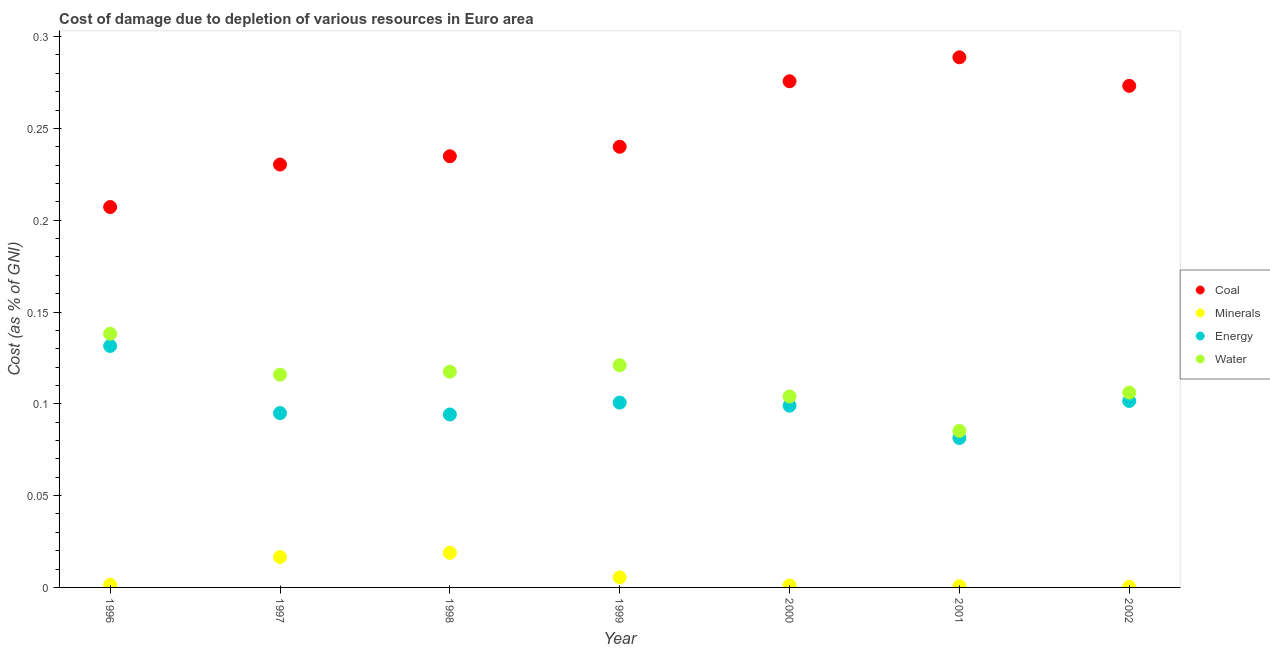How many different coloured dotlines are there?
Provide a short and direct response. 4. Is the number of dotlines equal to the number of legend labels?
Your answer should be compact. Yes. What is the cost of damage due to depletion of water in 1997?
Give a very brief answer. 0.12. Across all years, what is the maximum cost of damage due to depletion of water?
Provide a short and direct response. 0.14. Across all years, what is the minimum cost of damage due to depletion of coal?
Your answer should be very brief. 0.21. In which year was the cost of damage due to depletion of energy maximum?
Give a very brief answer. 1996. What is the total cost of damage due to depletion of coal in the graph?
Give a very brief answer. 1.75. What is the difference between the cost of damage due to depletion of water in 2000 and that in 2002?
Your answer should be very brief. -0. What is the difference between the cost of damage due to depletion of coal in 2001 and the cost of damage due to depletion of minerals in 2000?
Your response must be concise. 0.29. What is the average cost of damage due to depletion of coal per year?
Your answer should be compact. 0.25. In the year 2001, what is the difference between the cost of damage due to depletion of energy and cost of damage due to depletion of coal?
Ensure brevity in your answer.  -0.21. In how many years, is the cost of damage due to depletion of coal greater than 0.2 %?
Your answer should be very brief. 7. What is the ratio of the cost of damage due to depletion of water in 1998 to that in 1999?
Provide a succinct answer. 0.97. Is the cost of damage due to depletion of coal in 1997 less than that in 2002?
Ensure brevity in your answer.  Yes. Is the difference between the cost of damage due to depletion of water in 2001 and 2002 greater than the difference between the cost of damage due to depletion of minerals in 2001 and 2002?
Offer a terse response. No. What is the difference between the highest and the second highest cost of damage due to depletion of water?
Keep it short and to the point. 0.02. What is the difference between the highest and the lowest cost of damage due to depletion of minerals?
Your answer should be very brief. 0.02. Is the sum of the cost of damage due to depletion of minerals in 1997 and 1999 greater than the maximum cost of damage due to depletion of coal across all years?
Offer a terse response. No. Is it the case that in every year, the sum of the cost of damage due to depletion of coal and cost of damage due to depletion of minerals is greater than the sum of cost of damage due to depletion of water and cost of damage due to depletion of energy?
Provide a short and direct response. Yes. Is the cost of damage due to depletion of coal strictly greater than the cost of damage due to depletion of energy over the years?
Your answer should be compact. Yes. How many dotlines are there?
Provide a short and direct response. 4. What is the difference between two consecutive major ticks on the Y-axis?
Keep it short and to the point. 0.05. Are the values on the major ticks of Y-axis written in scientific E-notation?
Offer a terse response. No. How many legend labels are there?
Keep it short and to the point. 4. What is the title of the graph?
Provide a short and direct response. Cost of damage due to depletion of various resources in Euro area . What is the label or title of the Y-axis?
Offer a terse response. Cost (as % of GNI). What is the Cost (as % of GNI) of Coal in 1996?
Provide a short and direct response. 0.21. What is the Cost (as % of GNI) of Minerals in 1996?
Make the answer very short. 0. What is the Cost (as % of GNI) in Energy in 1996?
Your response must be concise. 0.13. What is the Cost (as % of GNI) in Water in 1996?
Offer a terse response. 0.14. What is the Cost (as % of GNI) of Coal in 1997?
Your response must be concise. 0.23. What is the Cost (as % of GNI) in Minerals in 1997?
Ensure brevity in your answer.  0.02. What is the Cost (as % of GNI) in Energy in 1997?
Ensure brevity in your answer.  0.09. What is the Cost (as % of GNI) in Water in 1997?
Offer a very short reply. 0.12. What is the Cost (as % of GNI) of Coal in 1998?
Your response must be concise. 0.23. What is the Cost (as % of GNI) of Minerals in 1998?
Keep it short and to the point. 0.02. What is the Cost (as % of GNI) of Energy in 1998?
Your answer should be compact. 0.09. What is the Cost (as % of GNI) of Water in 1998?
Make the answer very short. 0.12. What is the Cost (as % of GNI) in Coal in 1999?
Provide a succinct answer. 0.24. What is the Cost (as % of GNI) in Minerals in 1999?
Provide a short and direct response. 0.01. What is the Cost (as % of GNI) in Energy in 1999?
Provide a succinct answer. 0.1. What is the Cost (as % of GNI) of Water in 1999?
Your response must be concise. 0.12. What is the Cost (as % of GNI) in Coal in 2000?
Your answer should be compact. 0.28. What is the Cost (as % of GNI) in Minerals in 2000?
Keep it short and to the point. 0. What is the Cost (as % of GNI) in Energy in 2000?
Keep it short and to the point. 0.1. What is the Cost (as % of GNI) of Water in 2000?
Ensure brevity in your answer.  0.1. What is the Cost (as % of GNI) in Coal in 2001?
Ensure brevity in your answer.  0.29. What is the Cost (as % of GNI) of Minerals in 2001?
Give a very brief answer. 0. What is the Cost (as % of GNI) of Energy in 2001?
Your response must be concise. 0.08. What is the Cost (as % of GNI) in Water in 2001?
Your answer should be compact. 0.09. What is the Cost (as % of GNI) in Coal in 2002?
Make the answer very short. 0.27. What is the Cost (as % of GNI) in Minerals in 2002?
Make the answer very short. 0. What is the Cost (as % of GNI) in Energy in 2002?
Keep it short and to the point. 0.1. What is the Cost (as % of GNI) of Water in 2002?
Provide a succinct answer. 0.11. Across all years, what is the maximum Cost (as % of GNI) in Coal?
Your answer should be compact. 0.29. Across all years, what is the maximum Cost (as % of GNI) of Minerals?
Keep it short and to the point. 0.02. Across all years, what is the maximum Cost (as % of GNI) of Energy?
Give a very brief answer. 0.13. Across all years, what is the maximum Cost (as % of GNI) in Water?
Provide a short and direct response. 0.14. Across all years, what is the minimum Cost (as % of GNI) of Coal?
Your answer should be very brief. 0.21. Across all years, what is the minimum Cost (as % of GNI) in Minerals?
Your answer should be very brief. 0. Across all years, what is the minimum Cost (as % of GNI) in Energy?
Provide a short and direct response. 0.08. Across all years, what is the minimum Cost (as % of GNI) of Water?
Give a very brief answer. 0.09. What is the total Cost (as % of GNI) of Coal in the graph?
Provide a short and direct response. 1.75. What is the total Cost (as % of GNI) of Minerals in the graph?
Provide a succinct answer. 0.04. What is the total Cost (as % of GNI) in Energy in the graph?
Your answer should be very brief. 0.7. What is the total Cost (as % of GNI) in Water in the graph?
Provide a short and direct response. 0.79. What is the difference between the Cost (as % of GNI) in Coal in 1996 and that in 1997?
Your answer should be compact. -0.02. What is the difference between the Cost (as % of GNI) of Minerals in 1996 and that in 1997?
Provide a succinct answer. -0.02. What is the difference between the Cost (as % of GNI) of Energy in 1996 and that in 1997?
Offer a very short reply. 0.04. What is the difference between the Cost (as % of GNI) in Water in 1996 and that in 1997?
Ensure brevity in your answer.  0.02. What is the difference between the Cost (as % of GNI) in Coal in 1996 and that in 1998?
Make the answer very short. -0.03. What is the difference between the Cost (as % of GNI) of Minerals in 1996 and that in 1998?
Ensure brevity in your answer.  -0.02. What is the difference between the Cost (as % of GNI) of Energy in 1996 and that in 1998?
Your answer should be compact. 0.04. What is the difference between the Cost (as % of GNI) in Water in 1996 and that in 1998?
Ensure brevity in your answer.  0.02. What is the difference between the Cost (as % of GNI) in Coal in 1996 and that in 1999?
Your answer should be very brief. -0.03. What is the difference between the Cost (as % of GNI) in Minerals in 1996 and that in 1999?
Make the answer very short. -0. What is the difference between the Cost (as % of GNI) in Energy in 1996 and that in 1999?
Make the answer very short. 0.03. What is the difference between the Cost (as % of GNI) in Water in 1996 and that in 1999?
Provide a short and direct response. 0.02. What is the difference between the Cost (as % of GNI) in Coal in 1996 and that in 2000?
Offer a very short reply. -0.07. What is the difference between the Cost (as % of GNI) in Energy in 1996 and that in 2000?
Offer a terse response. 0.03. What is the difference between the Cost (as % of GNI) in Water in 1996 and that in 2000?
Offer a very short reply. 0.03. What is the difference between the Cost (as % of GNI) in Coal in 1996 and that in 2001?
Make the answer very short. -0.08. What is the difference between the Cost (as % of GNI) in Minerals in 1996 and that in 2001?
Provide a short and direct response. 0. What is the difference between the Cost (as % of GNI) in Energy in 1996 and that in 2001?
Your answer should be compact. 0.05. What is the difference between the Cost (as % of GNI) in Water in 1996 and that in 2001?
Offer a very short reply. 0.05. What is the difference between the Cost (as % of GNI) of Coal in 1996 and that in 2002?
Your response must be concise. -0.07. What is the difference between the Cost (as % of GNI) in Minerals in 1996 and that in 2002?
Provide a succinct answer. 0. What is the difference between the Cost (as % of GNI) of Energy in 1996 and that in 2002?
Your response must be concise. 0.03. What is the difference between the Cost (as % of GNI) of Water in 1996 and that in 2002?
Ensure brevity in your answer.  0.03. What is the difference between the Cost (as % of GNI) in Coal in 1997 and that in 1998?
Your answer should be very brief. -0. What is the difference between the Cost (as % of GNI) in Minerals in 1997 and that in 1998?
Ensure brevity in your answer.  -0. What is the difference between the Cost (as % of GNI) in Energy in 1997 and that in 1998?
Provide a short and direct response. 0. What is the difference between the Cost (as % of GNI) of Water in 1997 and that in 1998?
Give a very brief answer. -0. What is the difference between the Cost (as % of GNI) in Coal in 1997 and that in 1999?
Provide a succinct answer. -0.01. What is the difference between the Cost (as % of GNI) in Minerals in 1997 and that in 1999?
Offer a very short reply. 0.01. What is the difference between the Cost (as % of GNI) of Energy in 1997 and that in 1999?
Offer a very short reply. -0.01. What is the difference between the Cost (as % of GNI) of Water in 1997 and that in 1999?
Your response must be concise. -0.01. What is the difference between the Cost (as % of GNI) in Coal in 1997 and that in 2000?
Your response must be concise. -0.05. What is the difference between the Cost (as % of GNI) of Minerals in 1997 and that in 2000?
Make the answer very short. 0.02. What is the difference between the Cost (as % of GNI) in Energy in 1997 and that in 2000?
Your answer should be very brief. -0. What is the difference between the Cost (as % of GNI) of Water in 1997 and that in 2000?
Offer a terse response. 0.01. What is the difference between the Cost (as % of GNI) of Coal in 1997 and that in 2001?
Keep it short and to the point. -0.06. What is the difference between the Cost (as % of GNI) of Minerals in 1997 and that in 2001?
Provide a succinct answer. 0.02. What is the difference between the Cost (as % of GNI) of Energy in 1997 and that in 2001?
Your answer should be compact. 0.01. What is the difference between the Cost (as % of GNI) in Water in 1997 and that in 2001?
Give a very brief answer. 0.03. What is the difference between the Cost (as % of GNI) of Coal in 1997 and that in 2002?
Your answer should be very brief. -0.04. What is the difference between the Cost (as % of GNI) in Minerals in 1997 and that in 2002?
Your response must be concise. 0.02. What is the difference between the Cost (as % of GNI) in Energy in 1997 and that in 2002?
Give a very brief answer. -0.01. What is the difference between the Cost (as % of GNI) of Water in 1997 and that in 2002?
Give a very brief answer. 0.01. What is the difference between the Cost (as % of GNI) of Coal in 1998 and that in 1999?
Your answer should be very brief. -0.01. What is the difference between the Cost (as % of GNI) in Minerals in 1998 and that in 1999?
Offer a very short reply. 0.01. What is the difference between the Cost (as % of GNI) in Energy in 1998 and that in 1999?
Give a very brief answer. -0.01. What is the difference between the Cost (as % of GNI) of Water in 1998 and that in 1999?
Make the answer very short. -0. What is the difference between the Cost (as % of GNI) in Coal in 1998 and that in 2000?
Keep it short and to the point. -0.04. What is the difference between the Cost (as % of GNI) of Minerals in 1998 and that in 2000?
Your answer should be very brief. 0.02. What is the difference between the Cost (as % of GNI) in Energy in 1998 and that in 2000?
Offer a very short reply. -0. What is the difference between the Cost (as % of GNI) of Water in 1998 and that in 2000?
Your response must be concise. 0.01. What is the difference between the Cost (as % of GNI) of Coal in 1998 and that in 2001?
Keep it short and to the point. -0.05. What is the difference between the Cost (as % of GNI) of Minerals in 1998 and that in 2001?
Offer a very short reply. 0.02. What is the difference between the Cost (as % of GNI) in Energy in 1998 and that in 2001?
Keep it short and to the point. 0.01. What is the difference between the Cost (as % of GNI) in Water in 1998 and that in 2001?
Ensure brevity in your answer.  0.03. What is the difference between the Cost (as % of GNI) in Coal in 1998 and that in 2002?
Keep it short and to the point. -0.04. What is the difference between the Cost (as % of GNI) of Minerals in 1998 and that in 2002?
Provide a succinct answer. 0.02. What is the difference between the Cost (as % of GNI) of Energy in 1998 and that in 2002?
Your response must be concise. -0.01. What is the difference between the Cost (as % of GNI) of Water in 1998 and that in 2002?
Provide a short and direct response. 0.01. What is the difference between the Cost (as % of GNI) of Coal in 1999 and that in 2000?
Offer a very short reply. -0.04. What is the difference between the Cost (as % of GNI) in Minerals in 1999 and that in 2000?
Offer a terse response. 0. What is the difference between the Cost (as % of GNI) in Energy in 1999 and that in 2000?
Your answer should be very brief. 0. What is the difference between the Cost (as % of GNI) of Water in 1999 and that in 2000?
Keep it short and to the point. 0.02. What is the difference between the Cost (as % of GNI) of Coal in 1999 and that in 2001?
Offer a very short reply. -0.05. What is the difference between the Cost (as % of GNI) of Minerals in 1999 and that in 2001?
Ensure brevity in your answer.  0. What is the difference between the Cost (as % of GNI) of Energy in 1999 and that in 2001?
Your answer should be very brief. 0.02. What is the difference between the Cost (as % of GNI) in Water in 1999 and that in 2001?
Provide a short and direct response. 0.04. What is the difference between the Cost (as % of GNI) in Coal in 1999 and that in 2002?
Your answer should be compact. -0.03. What is the difference between the Cost (as % of GNI) in Minerals in 1999 and that in 2002?
Keep it short and to the point. 0.01. What is the difference between the Cost (as % of GNI) in Energy in 1999 and that in 2002?
Keep it short and to the point. -0. What is the difference between the Cost (as % of GNI) in Water in 1999 and that in 2002?
Give a very brief answer. 0.01. What is the difference between the Cost (as % of GNI) in Coal in 2000 and that in 2001?
Keep it short and to the point. -0.01. What is the difference between the Cost (as % of GNI) of Minerals in 2000 and that in 2001?
Offer a terse response. 0. What is the difference between the Cost (as % of GNI) of Energy in 2000 and that in 2001?
Make the answer very short. 0.02. What is the difference between the Cost (as % of GNI) in Water in 2000 and that in 2001?
Provide a short and direct response. 0.02. What is the difference between the Cost (as % of GNI) in Coal in 2000 and that in 2002?
Make the answer very short. 0. What is the difference between the Cost (as % of GNI) in Minerals in 2000 and that in 2002?
Offer a very short reply. 0. What is the difference between the Cost (as % of GNI) in Energy in 2000 and that in 2002?
Your response must be concise. -0. What is the difference between the Cost (as % of GNI) in Water in 2000 and that in 2002?
Offer a very short reply. -0. What is the difference between the Cost (as % of GNI) in Coal in 2001 and that in 2002?
Offer a very short reply. 0.02. What is the difference between the Cost (as % of GNI) of Minerals in 2001 and that in 2002?
Your answer should be compact. 0. What is the difference between the Cost (as % of GNI) in Energy in 2001 and that in 2002?
Make the answer very short. -0.02. What is the difference between the Cost (as % of GNI) in Water in 2001 and that in 2002?
Offer a terse response. -0.02. What is the difference between the Cost (as % of GNI) of Coal in 1996 and the Cost (as % of GNI) of Minerals in 1997?
Provide a short and direct response. 0.19. What is the difference between the Cost (as % of GNI) of Coal in 1996 and the Cost (as % of GNI) of Energy in 1997?
Offer a very short reply. 0.11. What is the difference between the Cost (as % of GNI) of Coal in 1996 and the Cost (as % of GNI) of Water in 1997?
Give a very brief answer. 0.09. What is the difference between the Cost (as % of GNI) in Minerals in 1996 and the Cost (as % of GNI) in Energy in 1997?
Your answer should be very brief. -0.09. What is the difference between the Cost (as % of GNI) in Minerals in 1996 and the Cost (as % of GNI) in Water in 1997?
Your answer should be very brief. -0.11. What is the difference between the Cost (as % of GNI) in Energy in 1996 and the Cost (as % of GNI) in Water in 1997?
Make the answer very short. 0.02. What is the difference between the Cost (as % of GNI) of Coal in 1996 and the Cost (as % of GNI) of Minerals in 1998?
Offer a very short reply. 0.19. What is the difference between the Cost (as % of GNI) of Coal in 1996 and the Cost (as % of GNI) of Energy in 1998?
Give a very brief answer. 0.11. What is the difference between the Cost (as % of GNI) of Coal in 1996 and the Cost (as % of GNI) of Water in 1998?
Make the answer very short. 0.09. What is the difference between the Cost (as % of GNI) in Minerals in 1996 and the Cost (as % of GNI) in Energy in 1998?
Offer a very short reply. -0.09. What is the difference between the Cost (as % of GNI) of Minerals in 1996 and the Cost (as % of GNI) of Water in 1998?
Offer a terse response. -0.12. What is the difference between the Cost (as % of GNI) of Energy in 1996 and the Cost (as % of GNI) of Water in 1998?
Make the answer very short. 0.01. What is the difference between the Cost (as % of GNI) in Coal in 1996 and the Cost (as % of GNI) in Minerals in 1999?
Your answer should be very brief. 0.2. What is the difference between the Cost (as % of GNI) of Coal in 1996 and the Cost (as % of GNI) of Energy in 1999?
Ensure brevity in your answer.  0.11. What is the difference between the Cost (as % of GNI) in Coal in 1996 and the Cost (as % of GNI) in Water in 1999?
Offer a terse response. 0.09. What is the difference between the Cost (as % of GNI) in Minerals in 1996 and the Cost (as % of GNI) in Energy in 1999?
Your answer should be very brief. -0.1. What is the difference between the Cost (as % of GNI) of Minerals in 1996 and the Cost (as % of GNI) of Water in 1999?
Keep it short and to the point. -0.12. What is the difference between the Cost (as % of GNI) in Energy in 1996 and the Cost (as % of GNI) in Water in 1999?
Your answer should be very brief. 0.01. What is the difference between the Cost (as % of GNI) of Coal in 1996 and the Cost (as % of GNI) of Minerals in 2000?
Ensure brevity in your answer.  0.21. What is the difference between the Cost (as % of GNI) of Coal in 1996 and the Cost (as % of GNI) of Energy in 2000?
Your response must be concise. 0.11. What is the difference between the Cost (as % of GNI) of Coal in 1996 and the Cost (as % of GNI) of Water in 2000?
Provide a succinct answer. 0.1. What is the difference between the Cost (as % of GNI) of Minerals in 1996 and the Cost (as % of GNI) of Energy in 2000?
Ensure brevity in your answer.  -0.1. What is the difference between the Cost (as % of GNI) of Minerals in 1996 and the Cost (as % of GNI) of Water in 2000?
Your answer should be very brief. -0.1. What is the difference between the Cost (as % of GNI) of Energy in 1996 and the Cost (as % of GNI) of Water in 2000?
Offer a very short reply. 0.03. What is the difference between the Cost (as % of GNI) of Coal in 1996 and the Cost (as % of GNI) of Minerals in 2001?
Ensure brevity in your answer.  0.21. What is the difference between the Cost (as % of GNI) of Coal in 1996 and the Cost (as % of GNI) of Energy in 2001?
Offer a terse response. 0.13. What is the difference between the Cost (as % of GNI) in Coal in 1996 and the Cost (as % of GNI) in Water in 2001?
Ensure brevity in your answer.  0.12. What is the difference between the Cost (as % of GNI) of Minerals in 1996 and the Cost (as % of GNI) of Energy in 2001?
Offer a terse response. -0.08. What is the difference between the Cost (as % of GNI) of Minerals in 1996 and the Cost (as % of GNI) of Water in 2001?
Provide a succinct answer. -0.08. What is the difference between the Cost (as % of GNI) in Energy in 1996 and the Cost (as % of GNI) in Water in 2001?
Provide a succinct answer. 0.05. What is the difference between the Cost (as % of GNI) of Coal in 1996 and the Cost (as % of GNI) of Minerals in 2002?
Ensure brevity in your answer.  0.21. What is the difference between the Cost (as % of GNI) in Coal in 1996 and the Cost (as % of GNI) in Energy in 2002?
Provide a short and direct response. 0.11. What is the difference between the Cost (as % of GNI) of Coal in 1996 and the Cost (as % of GNI) of Water in 2002?
Your answer should be very brief. 0.1. What is the difference between the Cost (as % of GNI) of Minerals in 1996 and the Cost (as % of GNI) of Energy in 2002?
Give a very brief answer. -0.1. What is the difference between the Cost (as % of GNI) of Minerals in 1996 and the Cost (as % of GNI) of Water in 2002?
Keep it short and to the point. -0.1. What is the difference between the Cost (as % of GNI) of Energy in 1996 and the Cost (as % of GNI) of Water in 2002?
Your response must be concise. 0.03. What is the difference between the Cost (as % of GNI) of Coal in 1997 and the Cost (as % of GNI) of Minerals in 1998?
Make the answer very short. 0.21. What is the difference between the Cost (as % of GNI) of Coal in 1997 and the Cost (as % of GNI) of Energy in 1998?
Offer a terse response. 0.14. What is the difference between the Cost (as % of GNI) of Coal in 1997 and the Cost (as % of GNI) of Water in 1998?
Your answer should be compact. 0.11. What is the difference between the Cost (as % of GNI) of Minerals in 1997 and the Cost (as % of GNI) of Energy in 1998?
Offer a very short reply. -0.08. What is the difference between the Cost (as % of GNI) of Minerals in 1997 and the Cost (as % of GNI) of Water in 1998?
Give a very brief answer. -0.1. What is the difference between the Cost (as % of GNI) of Energy in 1997 and the Cost (as % of GNI) of Water in 1998?
Provide a short and direct response. -0.02. What is the difference between the Cost (as % of GNI) in Coal in 1997 and the Cost (as % of GNI) in Minerals in 1999?
Provide a short and direct response. 0.22. What is the difference between the Cost (as % of GNI) in Coal in 1997 and the Cost (as % of GNI) in Energy in 1999?
Provide a short and direct response. 0.13. What is the difference between the Cost (as % of GNI) in Coal in 1997 and the Cost (as % of GNI) in Water in 1999?
Ensure brevity in your answer.  0.11. What is the difference between the Cost (as % of GNI) of Minerals in 1997 and the Cost (as % of GNI) of Energy in 1999?
Your answer should be very brief. -0.08. What is the difference between the Cost (as % of GNI) in Minerals in 1997 and the Cost (as % of GNI) in Water in 1999?
Your answer should be compact. -0.1. What is the difference between the Cost (as % of GNI) in Energy in 1997 and the Cost (as % of GNI) in Water in 1999?
Your answer should be very brief. -0.03. What is the difference between the Cost (as % of GNI) in Coal in 1997 and the Cost (as % of GNI) in Minerals in 2000?
Offer a very short reply. 0.23. What is the difference between the Cost (as % of GNI) in Coal in 1997 and the Cost (as % of GNI) in Energy in 2000?
Give a very brief answer. 0.13. What is the difference between the Cost (as % of GNI) in Coal in 1997 and the Cost (as % of GNI) in Water in 2000?
Provide a succinct answer. 0.13. What is the difference between the Cost (as % of GNI) of Minerals in 1997 and the Cost (as % of GNI) of Energy in 2000?
Your answer should be compact. -0.08. What is the difference between the Cost (as % of GNI) in Minerals in 1997 and the Cost (as % of GNI) in Water in 2000?
Ensure brevity in your answer.  -0.09. What is the difference between the Cost (as % of GNI) in Energy in 1997 and the Cost (as % of GNI) in Water in 2000?
Give a very brief answer. -0.01. What is the difference between the Cost (as % of GNI) in Coal in 1997 and the Cost (as % of GNI) in Minerals in 2001?
Your answer should be very brief. 0.23. What is the difference between the Cost (as % of GNI) of Coal in 1997 and the Cost (as % of GNI) of Energy in 2001?
Keep it short and to the point. 0.15. What is the difference between the Cost (as % of GNI) in Coal in 1997 and the Cost (as % of GNI) in Water in 2001?
Provide a succinct answer. 0.15. What is the difference between the Cost (as % of GNI) in Minerals in 1997 and the Cost (as % of GNI) in Energy in 2001?
Keep it short and to the point. -0.06. What is the difference between the Cost (as % of GNI) in Minerals in 1997 and the Cost (as % of GNI) in Water in 2001?
Provide a short and direct response. -0.07. What is the difference between the Cost (as % of GNI) of Energy in 1997 and the Cost (as % of GNI) of Water in 2001?
Ensure brevity in your answer.  0.01. What is the difference between the Cost (as % of GNI) of Coal in 1997 and the Cost (as % of GNI) of Minerals in 2002?
Keep it short and to the point. 0.23. What is the difference between the Cost (as % of GNI) in Coal in 1997 and the Cost (as % of GNI) in Energy in 2002?
Give a very brief answer. 0.13. What is the difference between the Cost (as % of GNI) of Coal in 1997 and the Cost (as % of GNI) of Water in 2002?
Keep it short and to the point. 0.12. What is the difference between the Cost (as % of GNI) in Minerals in 1997 and the Cost (as % of GNI) in Energy in 2002?
Keep it short and to the point. -0.09. What is the difference between the Cost (as % of GNI) in Minerals in 1997 and the Cost (as % of GNI) in Water in 2002?
Ensure brevity in your answer.  -0.09. What is the difference between the Cost (as % of GNI) in Energy in 1997 and the Cost (as % of GNI) in Water in 2002?
Your response must be concise. -0.01. What is the difference between the Cost (as % of GNI) in Coal in 1998 and the Cost (as % of GNI) in Minerals in 1999?
Offer a terse response. 0.23. What is the difference between the Cost (as % of GNI) in Coal in 1998 and the Cost (as % of GNI) in Energy in 1999?
Your answer should be compact. 0.13. What is the difference between the Cost (as % of GNI) of Coal in 1998 and the Cost (as % of GNI) of Water in 1999?
Your answer should be very brief. 0.11. What is the difference between the Cost (as % of GNI) in Minerals in 1998 and the Cost (as % of GNI) in Energy in 1999?
Keep it short and to the point. -0.08. What is the difference between the Cost (as % of GNI) in Minerals in 1998 and the Cost (as % of GNI) in Water in 1999?
Your answer should be very brief. -0.1. What is the difference between the Cost (as % of GNI) in Energy in 1998 and the Cost (as % of GNI) in Water in 1999?
Your response must be concise. -0.03. What is the difference between the Cost (as % of GNI) in Coal in 1998 and the Cost (as % of GNI) in Minerals in 2000?
Ensure brevity in your answer.  0.23. What is the difference between the Cost (as % of GNI) in Coal in 1998 and the Cost (as % of GNI) in Energy in 2000?
Provide a short and direct response. 0.14. What is the difference between the Cost (as % of GNI) of Coal in 1998 and the Cost (as % of GNI) of Water in 2000?
Give a very brief answer. 0.13. What is the difference between the Cost (as % of GNI) of Minerals in 1998 and the Cost (as % of GNI) of Energy in 2000?
Make the answer very short. -0.08. What is the difference between the Cost (as % of GNI) of Minerals in 1998 and the Cost (as % of GNI) of Water in 2000?
Your answer should be very brief. -0.09. What is the difference between the Cost (as % of GNI) in Energy in 1998 and the Cost (as % of GNI) in Water in 2000?
Offer a terse response. -0.01. What is the difference between the Cost (as % of GNI) of Coal in 1998 and the Cost (as % of GNI) of Minerals in 2001?
Your response must be concise. 0.23. What is the difference between the Cost (as % of GNI) of Coal in 1998 and the Cost (as % of GNI) of Energy in 2001?
Your answer should be compact. 0.15. What is the difference between the Cost (as % of GNI) in Coal in 1998 and the Cost (as % of GNI) in Water in 2001?
Your answer should be compact. 0.15. What is the difference between the Cost (as % of GNI) in Minerals in 1998 and the Cost (as % of GNI) in Energy in 2001?
Provide a short and direct response. -0.06. What is the difference between the Cost (as % of GNI) in Minerals in 1998 and the Cost (as % of GNI) in Water in 2001?
Ensure brevity in your answer.  -0.07. What is the difference between the Cost (as % of GNI) in Energy in 1998 and the Cost (as % of GNI) in Water in 2001?
Provide a short and direct response. 0.01. What is the difference between the Cost (as % of GNI) of Coal in 1998 and the Cost (as % of GNI) of Minerals in 2002?
Ensure brevity in your answer.  0.23. What is the difference between the Cost (as % of GNI) of Coal in 1998 and the Cost (as % of GNI) of Energy in 2002?
Offer a terse response. 0.13. What is the difference between the Cost (as % of GNI) in Coal in 1998 and the Cost (as % of GNI) in Water in 2002?
Your answer should be very brief. 0.13. What is the difference between the Cost (as % of GNI) of Minerals in 1998 and the Cost (as % of GNI) of Energy in 2002?
Give a very brief answer. -0.08. What is the difference between the Cost (as % of GNI) of Minerals in 1998 and the Cost (as % of GNI) of Water in 2002?
Your answer should be very brief. -0.09. What is the difference between the Cost (as % of GNI) in Energy in 1998 and the Cost (as % of GNI) in Water in 2002?
Ensure brevity in your answer.  -0.01. What is the difference between the Cost (as % of GNI) in Coal in 1999 and the Cost (as % of GNI) in Minerals in 2000?
Offer a terse response. 0.24. What is the difference between the Cost (as % of GNI) of Coal in 1999 and the Cost (as % of GNI) of Energy in 2000?
Your response must be concise. 0.14. What is the difference between the Cost (as % of GNI) in Coal in 1999 and the Cost (as % of GNI) in Water in 2000?
Offer a very short reply. 0.14. What is the difference between the Cost (as % of GNI) of Minerals in 1999 and the Cost (as % of GNI) of Energy in 2000?
Provide a succinct answer. -0.09. What is the difference between the Cost (as % of GNI) in Minerals in 1999 and the Cost (as % of GNI) in Water in 2000?
Offer a very short reply. -0.1. What is the difference between the Cost (as % of GNI) in Energy in 1999 and the Cost (as % of GNI) in Water in 2000?
Keep it short and to the point. -0. What is the difference between the Cost (as % of GNI) of Coal in 1999 and the Cost (as % of GNI) of Minerals in 2001?
Your answer should be compact. 0.24. What is the difference between the Cost (as % of GNI) in Coal in 1999 and the Cost (as % of GNI) in Energy in 2001?
Keep it short and to the point. 0.16. What is the difference between the Cost (as % of GNI) in Coal in 1999 and the Cost (as % of GNI) in Water in 2001?
Your response must be concise. 0.15. What is the difference between the Cost (as % of GNI) in Minerals in 1999 and the Cost (as % of GNI) in Energy in 2001?
Provide a short and direct response. -0.08. What is the difference between the Cost (as % of GNI) in Minerals in 1999 and the Cost (as % of GNI) in Water in 2001?
Your answer should be very brief. -0.08. What is the difference between the Cost (as % of GNI) of Energy in 1999 and the Cost (as % of GNI) of Water in 2001?
Your answer should be compact. 0.02. What is the difference between the Cost (as % of GNI) in Coal in 1999 and the Cost (as % of GNI) in Minerals in 2002?
Offer a very short reply. 0.24. What is the difference between the Cost (as % of GNI) of Coal in 1999 and the Cost (as % of GNI) of Energy in 2002?
Your response must be concise. 0.14. What is the difference between the Cost (as % of GNI) of Coal in 1999 and the Cost (as % of GNI) of Water in 2002?
Provide a short and direct response. 0.13. What is the difference between the Cost (as % of GNI) of Minerals in 1999 and the Cost (as % of GNI) of Energy in 2002?
Provide a short and direct response. -0.1. What is the difference between the Cost (as % of GNI) in Minerals in 1999 and the Cost (as % of GNI) in Water in 2002?
Ensure brevity in your answer.  -0.1. What is the difference between the Cost (as % of GNI) in Energy in 1999 and the Cost (as % of GNI) in Water in 2002?
Offer a very short reply. -0.01. What is the difference between the Cost (as % of GNI) of Coal in 2000 and the Cost (as % of GNI) of Minerals in 2001?
Provide a succinct answer. 0.28. What is the difference between the Cost (as % of GNI) in Coal in 2000 and the Cost (as % of GNI) in Energy in 2001?
Offer a very short reply. 0.19. What is the difference between the Cost (as % of GNI) in Coal in 2000 and the Cost (as % of GNI) in Water in 2001?
Provide a short and direct response. 0.19. What is the difference between the Cost (as % of GNI) of Minerals in 2000 and the Cost (as % of GNI) of Energy in 2001?
Ensure brevity in your answer.  -0.08. What is the difference between the Cost (as % of GNI) in Minerals in 2000 and the Cost (as % of GNI) in Water in 2001?
Provide a short and direct response. -0.08. What is the difference between the Cost (as % of GNI) of Energy in 2000 and the Cost (as % of GNI) of Water in 2001?
Offer a terse response. 0.01. What is the difference between the Cost (as % of GNI) of Coal in 2000 and the Cost (as % of GNI) of Minerals in 2002?
Provide a short and direct response. 0.28. What is the difference between the Cost (as % of GNI) in Coal in 2000 and the Cost (as % of GNI) in Energy in 2002?
Give a very brief answer. 0.17. What is the difference between the Cost (as % of GNI) in Coal in 2000 and the Cost (as % of GNI) in Water in 2002?
Ensure brevity in your answer.  0.17. What is the difference between the Cost (as % of GNI) in Minerals in 2000 and the Cost (as % of GNI) in Energy in 2002?
Make the answer very short. -0.1. What is the difference between the Cost (as % of GNI) of Minerals in 2000 and the Cost (as % of GNI) of Water in 2002?
Provide a short and direct response. -0.1. What is the difference between the Cost (as % of GNI) in Energy in 2000 and the Cost (as % of GNI) in Water in 2002?
Your answer should be compact. -0.01. What is the difference between the Cost (as % of GNI) in Coal in 2001 and the Cost (as % of GNI) in Minerals in 2002?
Your answer should be very brief. 0.29. What is the difference between the Cost (as % of GNI) of Coal in 2001 and the Cost (as % of GNI) of Energy in 2002?
Your answer should be compact. 0.19. What is the difference between the Cost (as % of GNI) in Coal in 2001 and the Cost (as % of GNI) in Water in 2002?
Offer a terse response. 0.18. What is the difference between the Cost (as % of GNI) in Minerals in 2001 and the Cost (as % of GNI) in Energy in 2002?
Ensure brevity in your answer.  -0.1. What is the difference between the Cost (as % of GNI) of Minerals in 2001 and the Cost (as % of GNI) of Water in 2002?
Your answer should be compact. -0.11. What is the difference between the Cost (as % of GNI) in Energy in 2001 and the Cost (as % of GNI) in Water in 2002?
Offer a terse response. -0.02. What is the average Cost (as % of GNI) of Minerals per year?
Keep it short and to the point. 0.01. What is the average Cost (as % of GNI) in Energy per year?
Provide a succinct answer. 0.1. What is the average Cost (as % of GNI) in Water per year?
Provide a succinct answer. 0.11. In the year 1996, what is the difference between the Cost (as % of GNI) in Coal and Cost (as % of GNI) in Minerals?
Your answer should be very brief. 0.21. In the year 1996, what is the difference between the Cost (as % of GNI) of Coal and Cost (as % of GNI) of Energy?
Offer a terse response. 0.08. In the year 1996, what is the difference between the Cost (as % of GNI) in Coal and Cost (as % of GNI) in Water?
Offer a terse response. 0.07. In the year 1996, what is the difference between the Cost (as % of GNI) of Minerals and Cost (as % of GNI) of Energy?
Offer a very short reply. -0.13. In the year 1996, what is the difference between the Cost (as % of GNI) in Minerals and Cost (as % of GNI) in Water?
Ensure brevity in your answer.  -0.14. In the year 1996, what is the difference between the Cost (as % of GNI) of Energy and Cost (as % of GNI) of Water?
Make the answer very short. -0.01. In the year 1997, what is the difference between the Cost (as % of GNI) of Coal and Cost (as % of GNI) of Minerals?
Keep it short and to the point. 0.21. In the year 1997, what is the difference between the Cost (as % of GNI) in Coal and Cost (as % of GNI) in Energy?
Provide a short and direct response. 0.14. In the year 1997, what is the difference between the Cost (as % of GNI) of Coal and Cost (as % of GNI) of Water?
Make the answer very short. 0.11. In the year 1997, what is the difference between the Cost (as % of GNI) of Minerals and Cost (as % of GNI) of Energy?
Your answer should be compact. -0.08. In the year 1997, what is the difference between the Cost (as % of GNI) of Minerals and Cost (as % of GNI) of Water?
Your answer should be compact. -0.1. In the year 1997, what is the difference between the Cost (as % of GNI) in Energy and Cost (as % of GNI) in Water?
Ensure brevity in your answer.  -0.02. In the year 1998, what is the difference between the Cost (as % of GNI) of Coal and Cost (as % of GNI) of Minerals?
Offer a terse response. 0.22. In the year 1998, what is the difference between the Cost (as % of GNI) of Coal and Cost (as % of GNI) of Energy?
Ensure brevity in your answer.  0.14. In the year 1998, what is the difference between the Cost (as % of GNI) in Coal and Cost (as % of GNI) in Water?
Ensure brevity in your answer.  0.12. In the year 1998, what is the difference between the Cost (as % of GNI) in Minerals and Cost (as % of GNI) in Energy?
Offer a terse response. -0.08. In the year 1998, what is the difference between the Cost (as % of GNI) of Minerals and Cost (as % of GNI) of Water?
Offer a terse response. -0.1. In the year 1998, what is the difference between the Cost (as % of GNI) in Energy and Cost (as % of GNI) in Water?
Your answer should be compact. -0.02. In the year 1999, what is the difference between the Cost (as % of GNI) of Coal and Cost (as % of GNI) of Minerals?
Offer a very short reply. 0.23. In the year 1999, what is the difference between the Cost (as % of GNI) in Coal and Cost (as % of GNI) in Energy?
Give a very brief answer. 0.14. In the year 1999, what is the difference between the Cost (as % of GNI) of Coal and Cost (as % of GNI) of Water?
Your answer should be compact. 0.12. In the year 1999, what is the difference between the Cost (as % of GNI) in Minerals and Cost (as % of GNI) in Energy?
Provide a short and direct response. -0.1. In the year 1999, what is the difference between the Cost (as % of GNI) in Minerals and Cost (as % of GNI) in Water?
Your answer should be compact. -0.12. In the year 1999, what is the difference between the Cost (as % of GNI) in Energy and Cost (as % of GNI) in Water?
Offer a terse response. -0.02. In the year 2000, what is the difference between the Cost (as % of GNI) of Coal and Cost (as % of GNI) of Minerals?
Offer a terse response. 0.27. In the year 2000, what is the difference between the Cost (as % of GNI) of Coal and Cost (as % of GNI) of Energy?
Your response must be concise. 0.18. In the year 2000, what is the difference between the Cost (as % of GNI) of Coal and Cost (as % of GNI) of Water?
Your response must be concise. 0.17. In the year 2000, what is the difference between the Cost (as % of GNI) in Minerals and Cost (as % of GNI) in Energy?
Make the answer very short. -0.1. In the year 2000, what is the difference between the Cost (as % of GNI) in Minerals and Cost (as % of GNI) in Water?
Your answer should be compact. -0.1. In the year 2000, what is the difference between the Cost (as % of GNI) in Energy and Cost (as % of GNI) in Water?
Make the answer very short. -0.01. In the year 2001, what is the difference between the Cost (as % of GNI) in Coal and Cost (as % of GNI) in Minerals?
Your answer should be compact. 0.29. In the year 2001, what is the difference between the Cost (as % of GNI) in Coal and Cost (as % of GNI) in Energy?
Offer a very short reply. 0.21. In the year 2001, what is the difference between the Cost (as % of GNI) of Coal and Cost (as % of GNI) of Water?
Provide a short and direct response. 0.2. In the year 2001, what is the difference between the Cost (as % of GNI) in Minerals and Cost (as % of GNI) in Energy?
Your response must be concise. -0.08. In the year 2001, what is the difference between the Cost (as % of GNI) of Minerals and Cost (as % of GNI) of Water?
Offer a terse response. -0.08. In the year 2001, what is the difference between the Cost (as % of GNI) in Energy and Cost (as % of GNI) in Water?
Make the answer very short. -0. In the year 2002, what is the difference between the Cost (as % of GNI) in Coal and Cost (as % of GNI) in Minerals?
Ensure brevity in your answer.  0.27. In the year 2002, what is the difference between the Cost (as % of GNI) in Coal and Cost (as % of GNI) in Energy?
Give a very brief answer. 0.17. In the year 2002, what is the difference between the Cost (as % of GNI) in Coal and Cost (as % of GNI) in Water?
Offer a terse response. 0.17. In the year 2002, what is the difference between the Cost (as % of GNI) in Minerals and Cost (as % of GNI) in Energy?
Your response must be concise. -0.1. In the year 2002, what is the difference between the Cost (as % of GNI) of Minerals and Cost (as % of GNI) of Water?
Make the answer very short. -0.11. In the year 2002, what is the difference between the Cost (as % of GNI) of Energy and Cost (as % of GNI) of Water?
Keep it short and to the point. -0. What is the ratio of the Cost (as % of GNI) in Coal in 1996 to that in 1997?
Provide a succinct answer. 0.9. What is the ratio of the Cost (as % of GNI) in Minerals in 1996 to that in 1997?
Your response must be concise. 0.08. What is the ratio of the Cost (as % of GNI) in Energy in 1996 to that in 1997?
Your answer should be very brief. 1.39. What is the ratio of the Cost (as % of GNI) in Water in 1996 to that in 1997?
Keep it short and to the point. 1.19. What is the ratio of the Cost (as % of GNI) of Coal in 1996 to that in 1998?
Your answer should be compact. 0.88. What is the ratio of the Cost (as % of GNI) of Minerals in 1996 to that in 1998?
Offer a terse response. 0.07. What is the ratio of the Cost (as % of GNI) in Energy in 1996 to that in 1998?
Your answer should be compact. 1.4. What is the ratio of the Cost (as % of GNI) in Water in 1996 to that in 1998?
Offer a very short reply. 1.18. What is the ratio of the Cost (as % of GNI) in Coal in 1996 to that in 1999?
Provide a short and direct response. 0.86. What is the ratio of the Cost (as % of GNI) in Minerals in 1996 to that in 1999?
Give a very brief answer. 0.25. What is the ratio of the Cost (as % of GNI) of Energy in 1996 to that in 1999?
Make the answer very short. 1.31. What is the ratio of the Cost (as % of GNI) in Water in 1996 to that in 1999?
Make the answer very short. 1.14. What is the ratio of the Cost (as % of GNI) in Coal in 1996 to that in 2000?
Ensure brevity in your answer.  0.75. What is the ratio of the Cost (as % of GNI) of Minerals in 1996 to that in 2000?
Keep it short and to the point. 1.25. What is the ratio of the Cost (as % of GNI) of Energy in 1996 to that in 2000?
Your answer should be very brief. 1.33. What is the ratio of the Cost (as % of GNI) in Water in 1996 to that in 2000?
Provide a short and direct response. 1.33. What is the ratio of the Cost (as % of GNI) of Coal in 1996 to that in 2001?
Make the answer very short. 0.72. What is the ratio of the Cost (as % of GNI) of Minerals in 1996 to that in 2001?
Provide a short and direct response. 2.12. What is the ratio of the Cost (as % of GNI) of Energy in 1996 to that in 2001?
Provide a succinct answer. 1.62. What is the ratio of the Cost (as % of GNI) in Water in 1996 to that in 2001?
Ensure brevity in your answer.  1.62. What is the ratio of the Cost (as % of GNI) of Coal in 1996 to that in 2002?
Your answer should be compact. 0.76. What is the ratio of the Cost (as % of GNI) in Minerals in 1996 to that in 2002?
Make the answer very short. 4.28. What is the ratio of the Cost (as % of GNI) in Energy in 1996 to that in 2002?
Provide a succinct answer. 1.3. What is the ratio of the Cost (as % of GNI) of Water in 1996 to that in 2002?
Provide a short and direct response. 1.3. What is the ratio of the Cost (as % of GNI) of Coal in 1997 to that in 1998?
Offer a very short reply. 0.98. What is the ratio of the Cost (as % of GNI) of Minerals in 1997 to that in 1998?
Keep it short and to the point. 0.88. What is the ratio of the Cost (as % of GNI) of Water in 1997 to that in 1998?
Offer a terse response. 0.99. What is the ratio of the Cost (as % of GNI) of Coal in 1997 to that in 1999?
Offer a terse response. 0.96. What is the ratio of the Cost (as % of GNI) of Minerals in 1997 to that in 1999?
Provide a succinct answer. 3.02. What is the ratio of the Cost (as % of GNI) in Energy in 1997 to that in 1999?
Provide a short and direct response. 0.94. What is the ratio of the Cost (as % of GNI) of Water in 1997 to that in 1999?
Offer a terse response. 0.96. What is the ratio of the Cost (as % of GNI) in Coal in 1997 to that in 2000?
Your answer should be very brief. 0.84. What is the ratio of the Cost (as % of GNI) in Minerals in 1997 to that in 2000?
Keep it short and to the point. 15.24. What is the ratio of the Cost (as % of GNI) of Water in 1997 to that in 2000?
Ensure brevity in your answer.  1.11. What is the ratio of the Cost (as % of GNI) in Coal in 1997 to that in 2001?
Your response must be concise. 0.8. What is the ratio of the Cost (as % of GNI) in Minerals in 1997 to that in 2001?
Your answer should be compact. 25.88. What is the ratio of the Cost (as % of GNI) in Energy in 1997 to that in 2001?
Keep it short and to the point. 1.17. What is the ratio of the Cost (as % of GNI) of Water in 1997 to that in 2001?
Offer a very short reply. 1.36. What is the ratio of the Cost (as % of GNI) in Coal in 1997 to that in 2002?
Provide a succinct answer. 0.84. What is the ratio of the Cost (as % of GNI) of Minerals in 1997 to that in 2002?
Provide a short and direct response. 52.34. What is the ratio of the Cost (as % of GNI) in Energy in 1997 to that in 2002?
Keep it short and to the point. 0.94. What is the ratio of the Cost (as % of GNI) in Water in 1997 to that in 2002?
Your answer should be very brief. 1.09. What is the ratio of the Cost (as % of GNI) in Coal in 1998 to that in 1999?
Your answer should be very brief. 0.98. What is the ratio of the Cost (as % of GNI) of Minerals in 1998 to that in 1999?
Give a very brief answer. 3.44. What is the ratio of the Cost (as % of GNI) in Energy in 1998 to that in 1999?
Give a very brief answer. 0.94. What is the ratio of the Cost (as % of GNI) in Water in 1998 to that in 1999?
Make the answer very short. 0.97. What is the ratio of the Cost (as % of GNI) of Coal in 1998 to that in 2000?
Ensure brevity in your answer.  0.85. What is the ratio of the Cost (as % of GNI) of Minerals in 1998 to that in 2000?
Make the answer very short. 17.37. What is the ratio of the Cost (as % of GNI) in Energy in 1998 to that in 2000?
Ensure brevity in your answer.  0.95. What is the ratio of the Cost (as % of GNI) in Water in 1998 to that in 2000?
Keep it short and to the point. 1.13. What is the ratio of the Cost (as % of GNI) in Coal in 1998 to that in 2001?
Give a very brief answer. 0.81. What is the ratio of the Cost (as % of GNI) of Minerals in 1998 to that in 2001?
Make the answer very short. 29.5. What is the ratio of the Cost (as % of GNI) in Energy in 1998 to that in 2001?
Your answer should be compact. 1.16. What is the ratio of the Cost (as % of GNI) in Water in 1998 to that in 2001?
Offer a terse response. 1.38. What is the ratio of the Cost (as % of GNI) in Coal in 1998 to that in 2002?
Your response must be concise. 0.86. What is the ratio of the Cost (as % of GNI) in Minerals in 1998 to that in 2002?
Provide a short and direct response. 59.67. What is the ratio of the Cost (as % of GNI) of Energy in 1998 to that in 2002?
Ensure brevity in your answer.  0.93. What is the ratio of the Cost (as % of GNI) of Water in 1998 to that in 2002?
Make the answer very short. 1.11. What is the ratio of the Cost (as % of GNI) of Coal in 1999 to that in 2000?
Provide a short and direct response. 0.87. What is the ratio of the Cost (as % of GNI) of Minerals in 1999 to that in 2000?
Ensure brevity in your answer.  5.05. What is the ratio of the Cost (as % of GNI) in Energy in 1999 to that in 2000?
Give a very brief answer. 1.02. What is the ratio of the Cost (as % of GNI) of Water in 1999 to that in 2000?
Keep it short and to the point. 1.16. What is the ratio of the Cost (as % of GNI) in Coal in 1999 to that in 2001?
Provide a succinct answer. 0.83. What is the ratio of the Cost (as % of GNI) in Minerals in 1999 to that in 2001?
Offer a terse response. 8.58. What is the ratio of the Cost (as % of GNI) of Energy in 1999 to that in 2001?
Offer a very short reply. 1.24. What is the ratio of the Cost (as % of GNI) of Water in 1999 to that in 2001?
Offer a terse response. 1.42. What is the ratio of the Cost (as % of GNI) of Coal in 1999 to that in 2002?
Keep it short and to the point. 0.88. What is the ratio of the Cost (as % of GNI) in Minerals in 1999 to that in 2002?
Your response must be concise. 17.36. What is the ratio of the Cost (as % of GNI) in Energy in 1999 to that in 2002?
Your answer should be very brief. 0.99. What is the ratio of the Cost (as % of GNI) in Water in 1999 to that in 2002?
Offer a very short reply. 1.14. What is the ratio of the Cost (as % of GNI) in Coal in 2000 to that in 2001?
Offer a very short reply. 0.95. What is the ratio of the Cost (as % of GNI) of Minerals in 2000 to that in 2001?
Make the answer very short. 1.7. What is the ratio of the Cost (as % of GNI) of Energy in 2000 to that in 2001?
Provide a short and direct response. 1.22. What is the ratio of the Cost (as % of GNI) in Water in 2000 to that in 2001?
Ensure brevity in your answer.  1.22. What is the ratio of the Cost (as % of GNI) of Coal in 2000 to that in 2002?
Your answer should be compact. 1.01. What is the ratio of the Cost (as % of GNI) of Minerals in 2000 to that in 2002?
Make the answer very short. 3.43. What is the ratio of the Cost (as % of GNI) in Water in 2000 to that in 2002?
Your answer should be compact. 0.98. What is the ratio of the Cost (as % of GNI) in Coal in 2001 to that in 2002?
Provide a short and direct response. 1.06. What is the ratio of the Cost (as % of GNI) in Minerals in 2001 to that in 2002?
Offer a terse response. 2.02. What is the ratio of the Cost (as % of GNI) in Energy in 2001 to that in 2002?
Offer a very short reply. 0.8. What is the ratio of the Cost (as % of GNI) of Water in 2001 to that in 2002?
Give a very brief answer. 0.8. What is the difference between the highest and the second highest Cost (as % of GNI) of Coal?
Provide a succinct answer. 0.01. What is the difference between the highest and the second highest Cost (as % of GNI) of Minerals?
Provide a short and direct response. 0. What is the difference between the highest and the second highest Cost (as % of GNI) in Energy?
Your response must be concise. 0.03. What is the difference between the highest and the second highest Cost (as % of GNI) in Water?
Provide a short and direct response. 0.02. What is the difference between the highest and the lowest Cost (as % of GNI) in Coal?
Your answer should be compact. 0.08. What is the difference between the highest and the lowest Cost (as % of GNI) in Minerals?
Provide a short and direct response. 0.02. What is the difference between the highest and the lowest Cost (as % of GNI) in Energy?
Provide a succinct answer. 0.05. What is the difference between the highest and the lowest Cost (as % of GNI) in Water?
Your answer should be very brief. 0.05. 